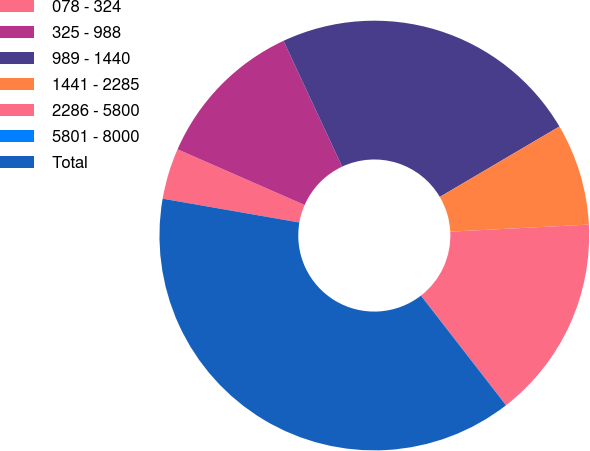Convert chart. <chart><loc_0><loc_0><loc_500><loc_500><pie_chart><fcel>078 - 324<fcel>325 - 988<fcel>989 - 1440<fcel>1441 - 2285<fcel>2286 - 5800<fcel>5801 - 8000<fcel>Total<nl><fcel>3.83%<fcel>11.48%<fcel>23.47%<fcel>7.66%<fcel>15.3%<fcel>0.01%<fcel>38.24%<nl></chart> 